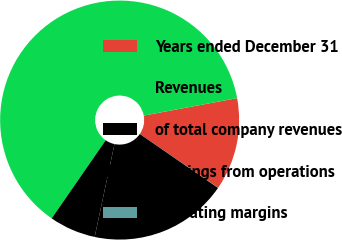Convert chart to OTSL. <chart><loc_0><loc_0><loc_500><loc_500><pie_chart><fcel>Years ended December 31<fcel>Revenues<fcel>of total company revenues<fcel>Earnings from operations<fcel>Operating margins<nl><fcel>12.51%<fcel>62.43%<fcel>6.27%<fcel>18.75%<fcel>0.03%<nl></chart> 